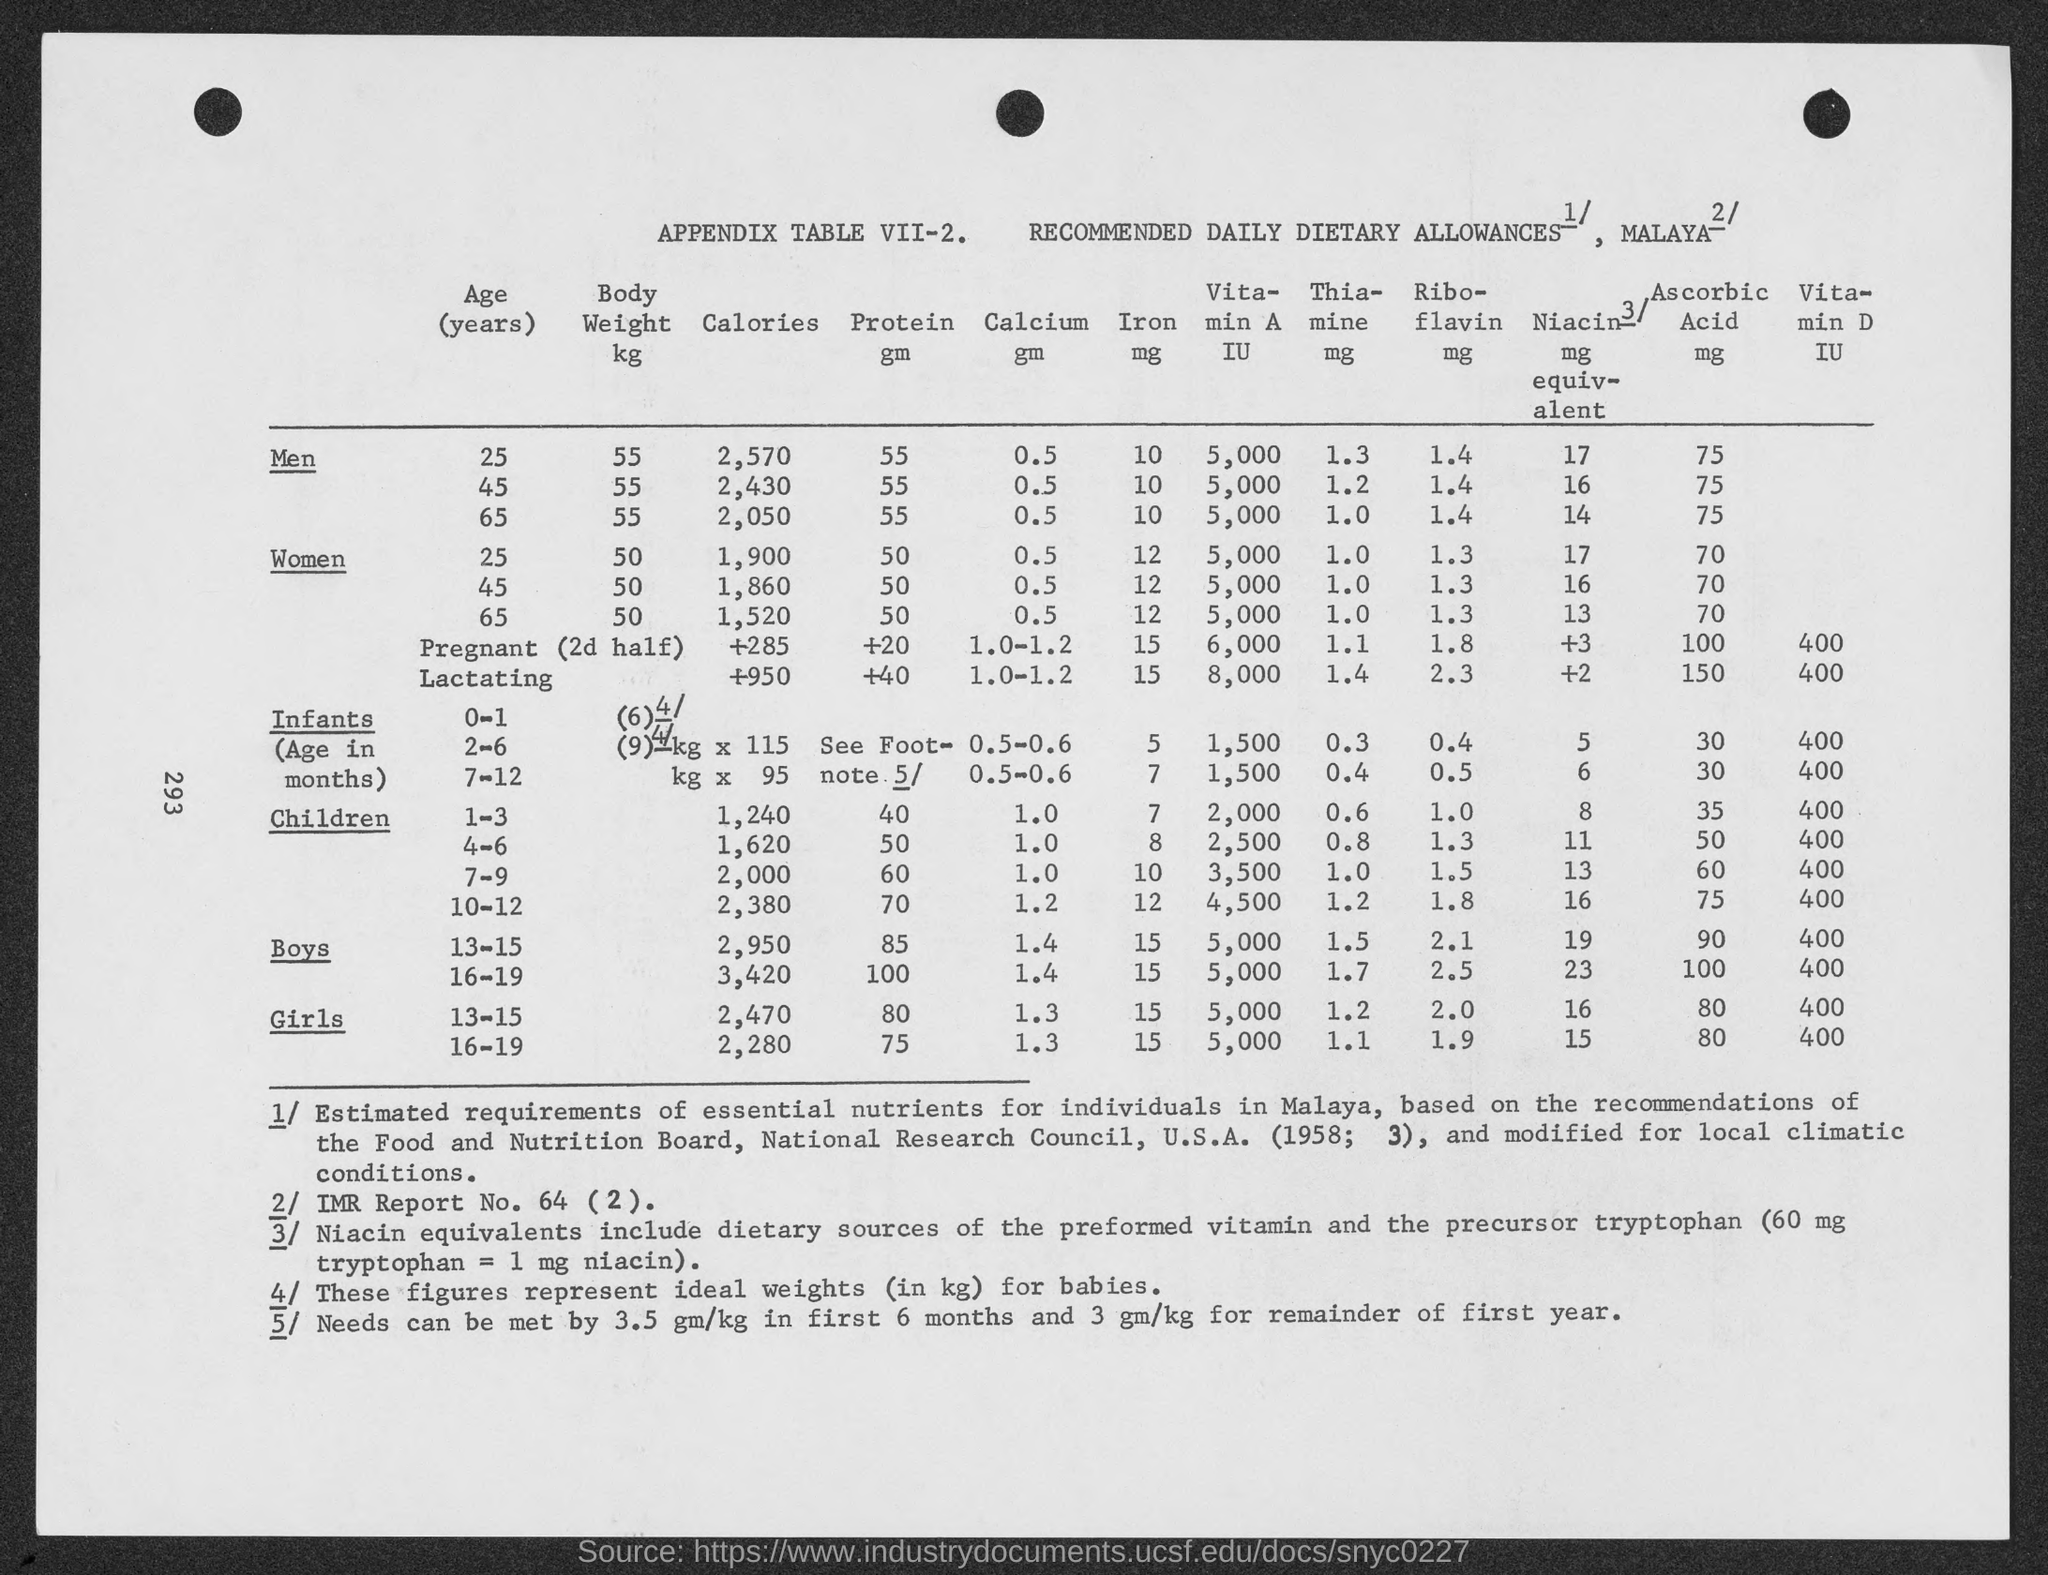What is the body weight of a 25 year old men from the table in kg?
Provide a short and direct response. 55. How much calories are there for 25 year old Men ?
Give a very brief answer. 2,570. 